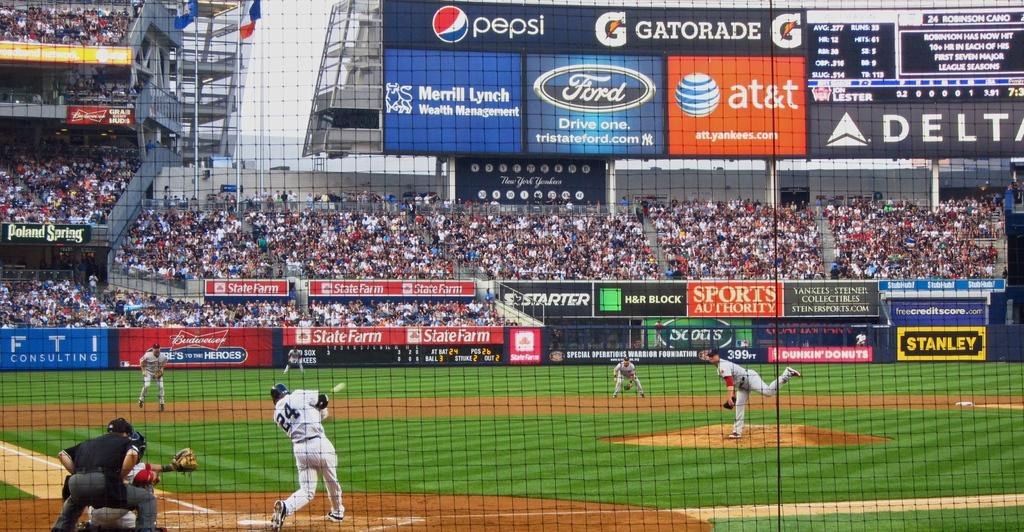<image>
Provide a brief description of the given image. The outfield of a baseball stadium has several advertisements, including Pepsi and Gatorade. 